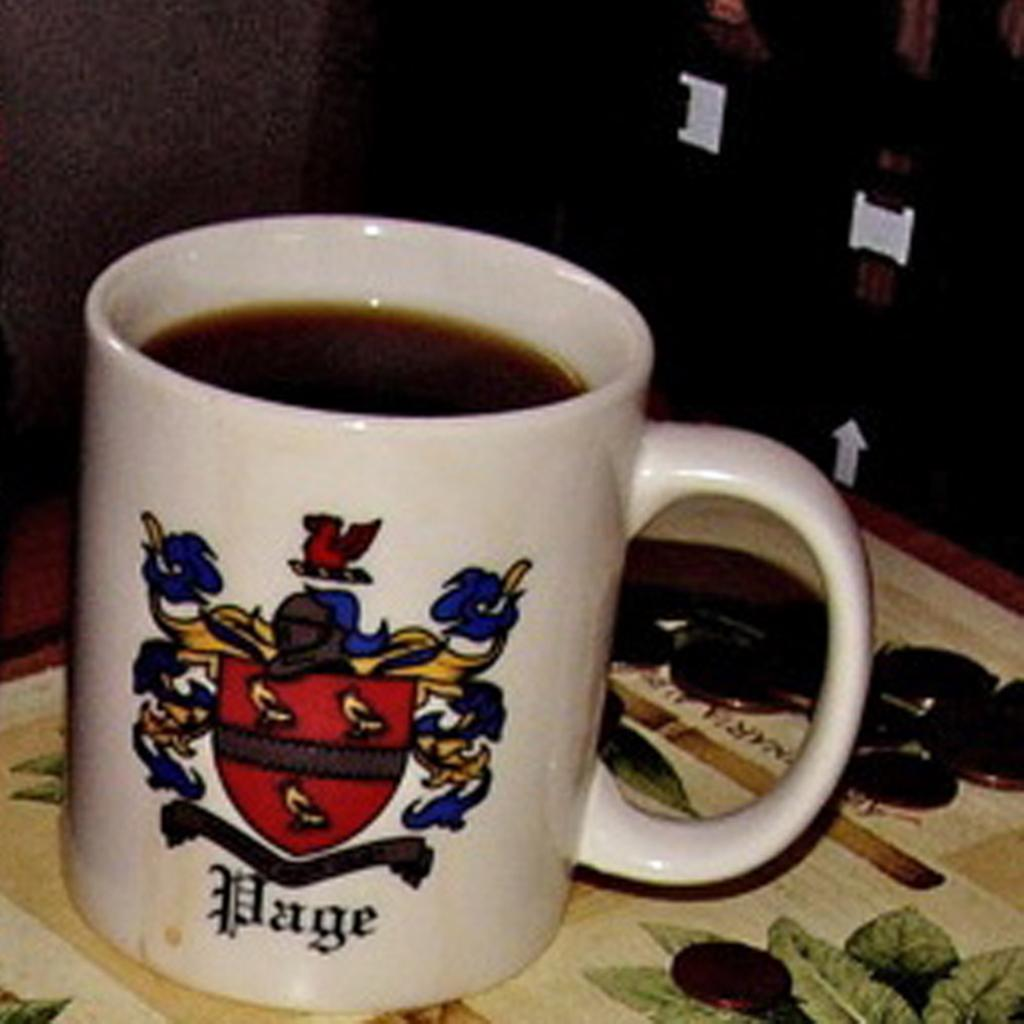<image>
Provide a brief description of the given image. A white coffee mug with a coat of arms and the name Page 